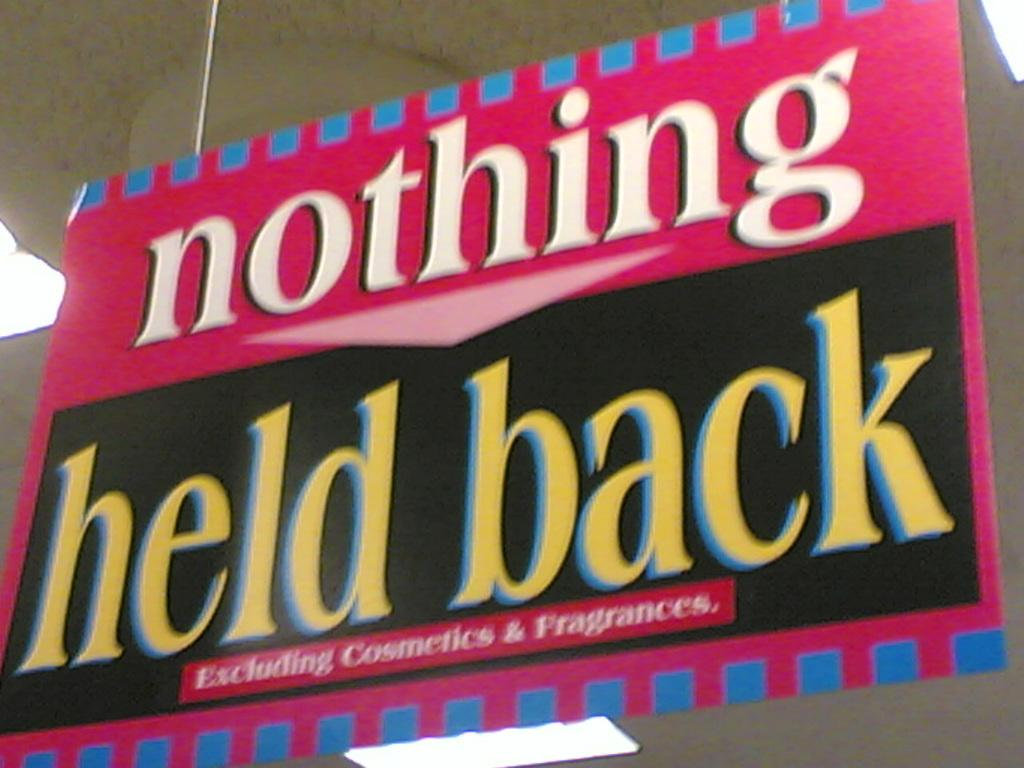<image>
Describe the image concisely. a poster that says 'nothing held back' on it 